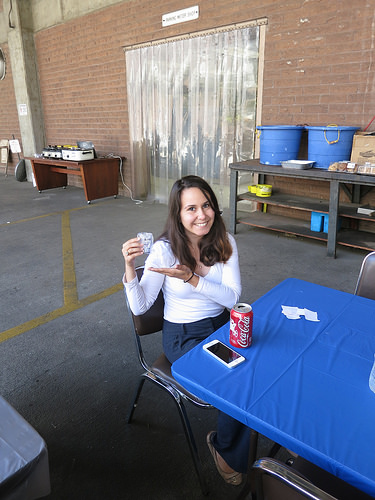<image>
Is the column in front of the doorway? No. The column is not in front of the doorway. The spatial positioning shows a different relationship between these objects. 